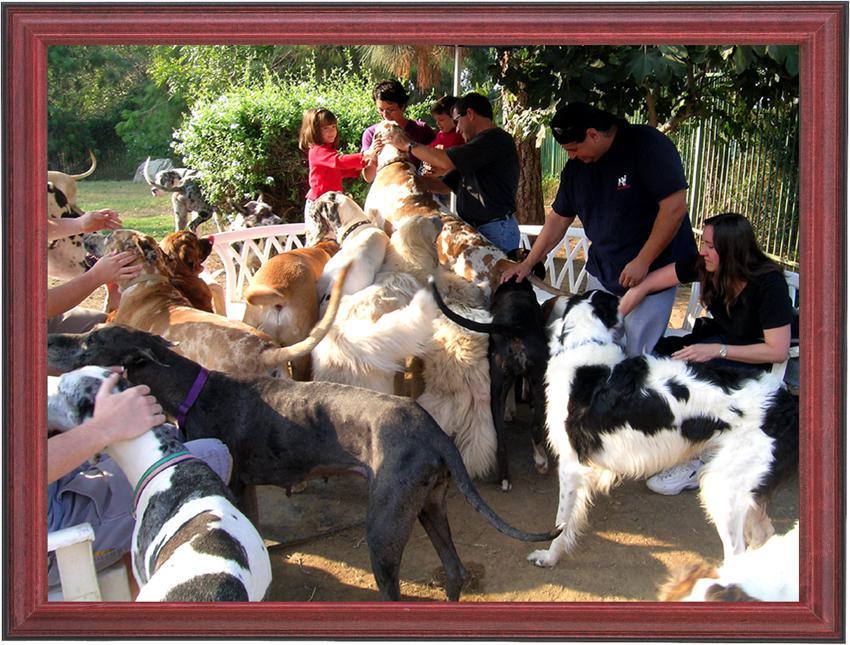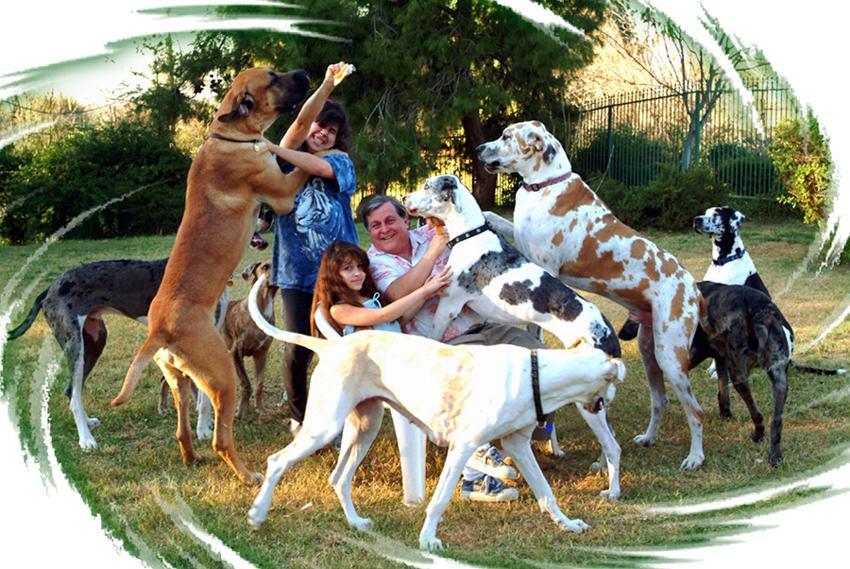The first image is the image on the left, the second image is the image on the right. Considering the images on both sides, is "An image contains no more than two hound dogs." valid? Answer yes or no. No. 